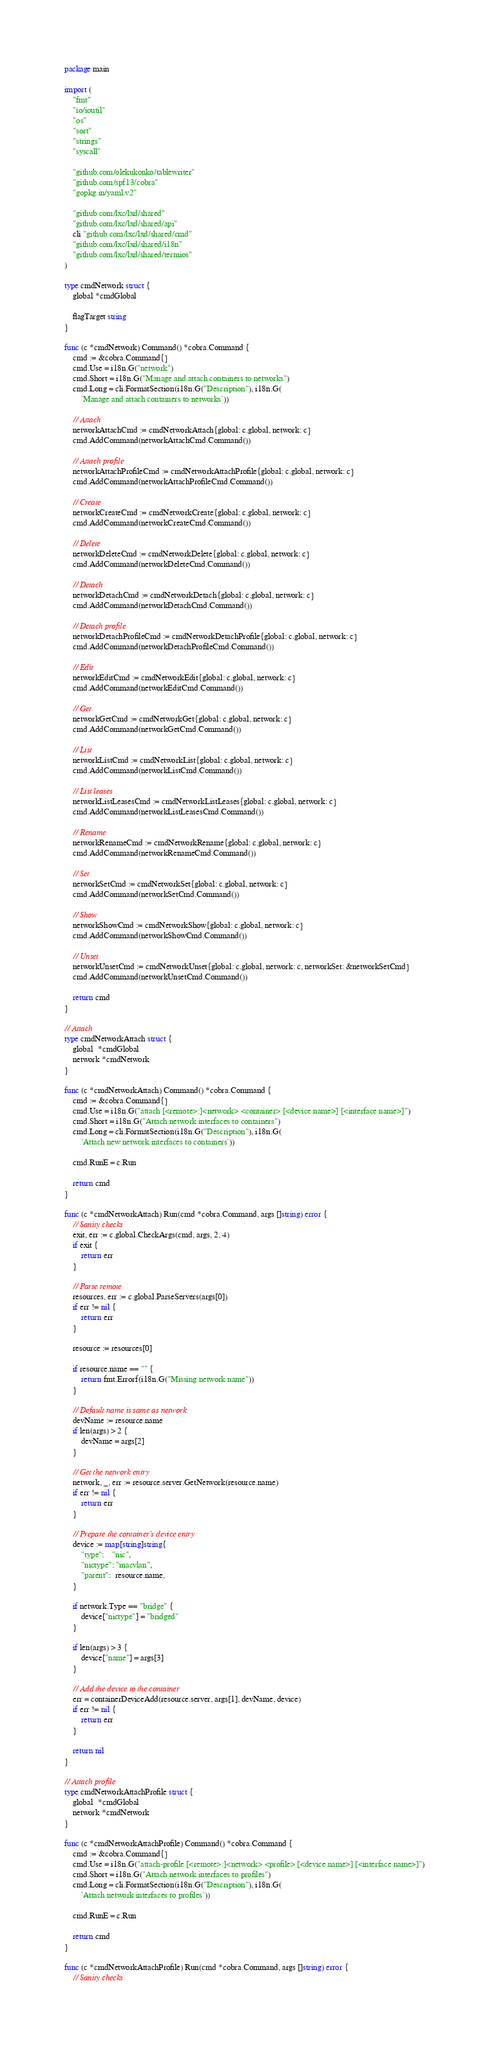<code> <loc_0><loc_0><loc_500><loc_500><_Go_>package main

import (
	"fmt"
	"io/ioutil"
	"os"
	"sort"
	"strings"
	"syscall"

	"github.com/olekukonko/tablewriter"
	"github.com/spf13/cobra"
	"gopkg.in/yaml.v2"

	"github.com/lxc/lxd/shared"
	"github.com/lxc/lxd/shared/api"
	cli "github.com/lxc/lxd/shared/cmd"
	"github.com/lxc/lxd/shared/i18n"
	"github.com/lxc/lxd/shared/termios"
)

type cmdNetwork struct {
	global *cmdGlobal

	flagTarget string
}

func (c *cmdNetwork) Command() *cobra.Command {
	cmd := &cobra.Command{}
	cmd.Use = i18n.G("network")
	cmd.Short = i18n.G("Manage and attach containers to networks")
	cmd.Long = cli.FormatSection(i18n.G("Description"), i18n.G(
		`Manage and attach containers to networks`))

	// Attach
	networkAttachCmd := cmdNetworkAttach{global: c.global, network: c}
	cmd.AddCommand(networkAttachCmd.Command())

	// Attach profile
	networkAttachProfileCmd := cmdNetworkAttachProfile{global: c.global, network: c}
	cmd.AddCommand(networkAttachProfileCmd.Command())

	// Create
	networkCreateCmd := cmdNetworkCreate{global: c.global, network: c}
	cmd.AddCommand(networkCreateCmd.Command())

	// Delete
	networkDeleteCmd := cmdNetworkDelete{global: c.global, network: c}
	cmd.AddCommand(networkDeleteCmd.Command())

	// Detach
	networkDetachCmd := cmdNetworkDetach{global: c.global, network: c}
	cmd.AddCommand(networkDetachCmd.Command())

	// Detach profile
	networkDetachProfileCmd := cmdNetworkDetachProfile{global: c.global, network: c}
	cmd.AddCommand(networkDetachProfileCmd.Command())

	// Edit
	networkEditCmd := cmdNetworkEdit{global: c.global, network: c}
	cmd.AddCommand(networkEditCmd.Command())

	// Get
	networkGetCmd := cmdNetworkGet{global: c.global, network: c}
	cmd.AddCommand(networkGetCmd.Command())

	// List
	networkListCmd := cmdNetworkList{global: c.global, network: c}
	cmd.AddCommand(networkListCmd.Command())

	// List leases
	networkListLeasesCmd := cmdNetworkListLeases{global: c.global, network: c}
	cmd.AddCommand(networkListLeasesCmd.Command())

	// Rename
	networkRenameCmd := cmdNetworkRename{global: c.global, network: c}
	cmd.AddCommand(networkRenameCmd.Command())

	// Set
	networkSetCmd := cmdNetworkSet{global: c.global, network: c}
	cmd.AddCommand(networkSetCmd.Command())

	// Show
	networkShowCmd := cmdNetworkShow{global: c.global, network: c}
	cmd.AddCommand(networkShowCmd.Command())

	// Unset
	networkUnsetCmd := cmdNetworkUnset{global: c.global, network: c, networkSet: &networkSetCmd}
	cmd.AddCommand(networkUnsetCmd.Command())

	return cmd
}

// Attach
type cmdNetworkAttach struct {
	global  *cmdGlobal
	network *cmdNetwork
}

func (c *cmdNetworkAttach) Command() *cobra.Command {
	cmd := &cobra.Command{}
	cmd.Use = i18n.G("attach [<remote>:]<network> <container> [<device name>] [<interface name>]")
	cmd.Short = i18n.G("Attach network interfaces to containers")
	cmd.Long = cli.FormatSection(i18n.G("Description"), i18n.G(
		`Attach new network interfaces to containers`))

	cmd.RunE = c.Run

	return cmd
}

func (c *cmdNetworkAttach) Run(cmd *cobra.Command, args []string) error {
	// Sanity checks
	exit, err := c.global.CheckArgs(cmd, args, 2, 4)
	if exit {
		return err
	}

	// Parse remote
	resources, err := c.global.ParseServers(args[0])
	if err != nil {
		return err
	}

	resource := resources[0]

	if resource.name == "" {
		return fmt.Errorf(i18n.G("Missing network name"))
	}

	// Default name is same as network
	devName := resource.name
	if len(args) > 2 {
		devName = args[2]
	}

	// Get the network entry
	network, _, err := resource.server.GetNetwork(resource.name)
	if err != nil {
		return err
	}

	// Prepare the container's device entry
	device := map[string]string{
		"type":    "nic",
		"nictype": "macvlan",
		"parent":  resource.name,
	}

	if network.Type == "bridge" {
		device["nictype"] = "bridged"
	}

	if len(args) > 3 {
		device["name"] = args[3]
	}

	// Add the device to the container
	err = containerDeviceAdd(resource.server, args[1], devName, device)
	if err != nil {
		return err
	}

	return nil
}

// Attach profile
type cmdNetworkAttachProfile struct {
	global  *cmdGlobal
	network *cmdNetwork
}

func (c *cmdNetworkAttachProfile) Command() *cobra.Command {
	cmd := &cobra.Command{}
	cmd.Use = i18n.G("attach-profile [<remote>:]<network> <profile> [<device name>] [<interface name>]")
	cmd.Short = i18n.G("Attach network interfaces to profiles")
	cmd.Long = cli.FormatSection(i18n.G("Description"), i18n.G(
		`Attach network interfaces to profiles`))

	cmd.RunE = c.Run

	return cmd
}

func (c *cmdNetworkAttachProfile) Run(cmd *cobra.Command, args []string) error {
	// Sanity checks</code> 